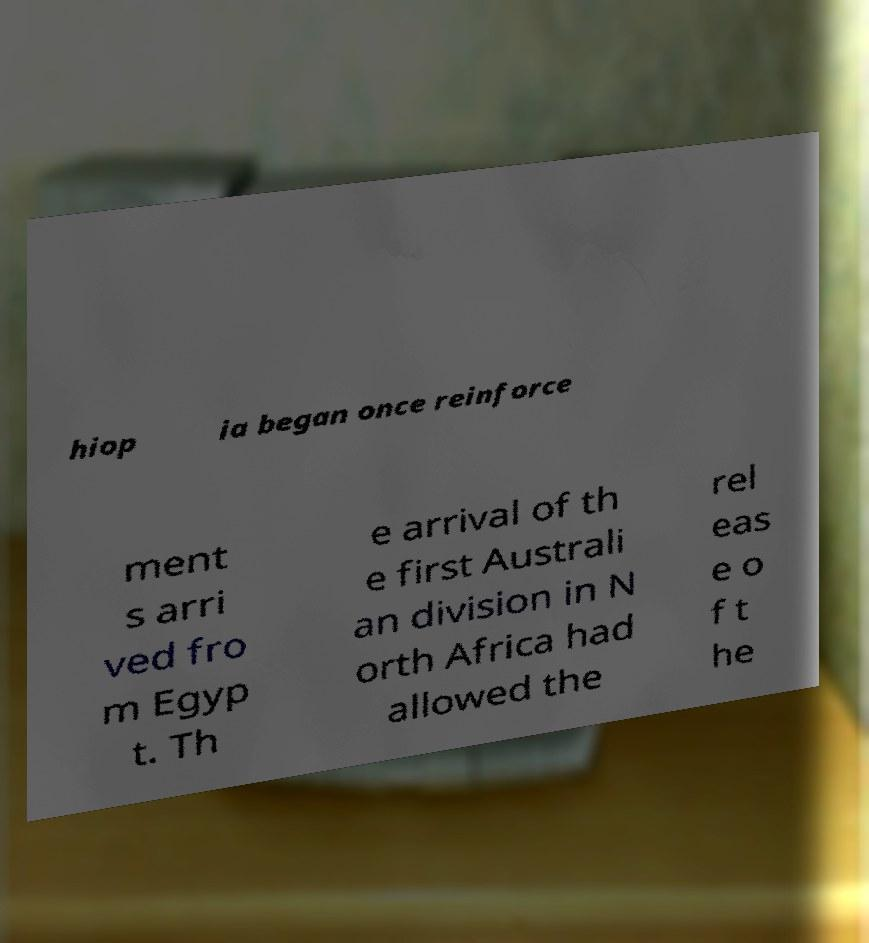What messages or text are displayed in this image? I need them in a readable, typed format. hiop ia began once reinforce ment s arri ved fro m Egyp t. Th e arrival of th e first Australi an division in N orth Africa had allowed the rel eas e o f t he 